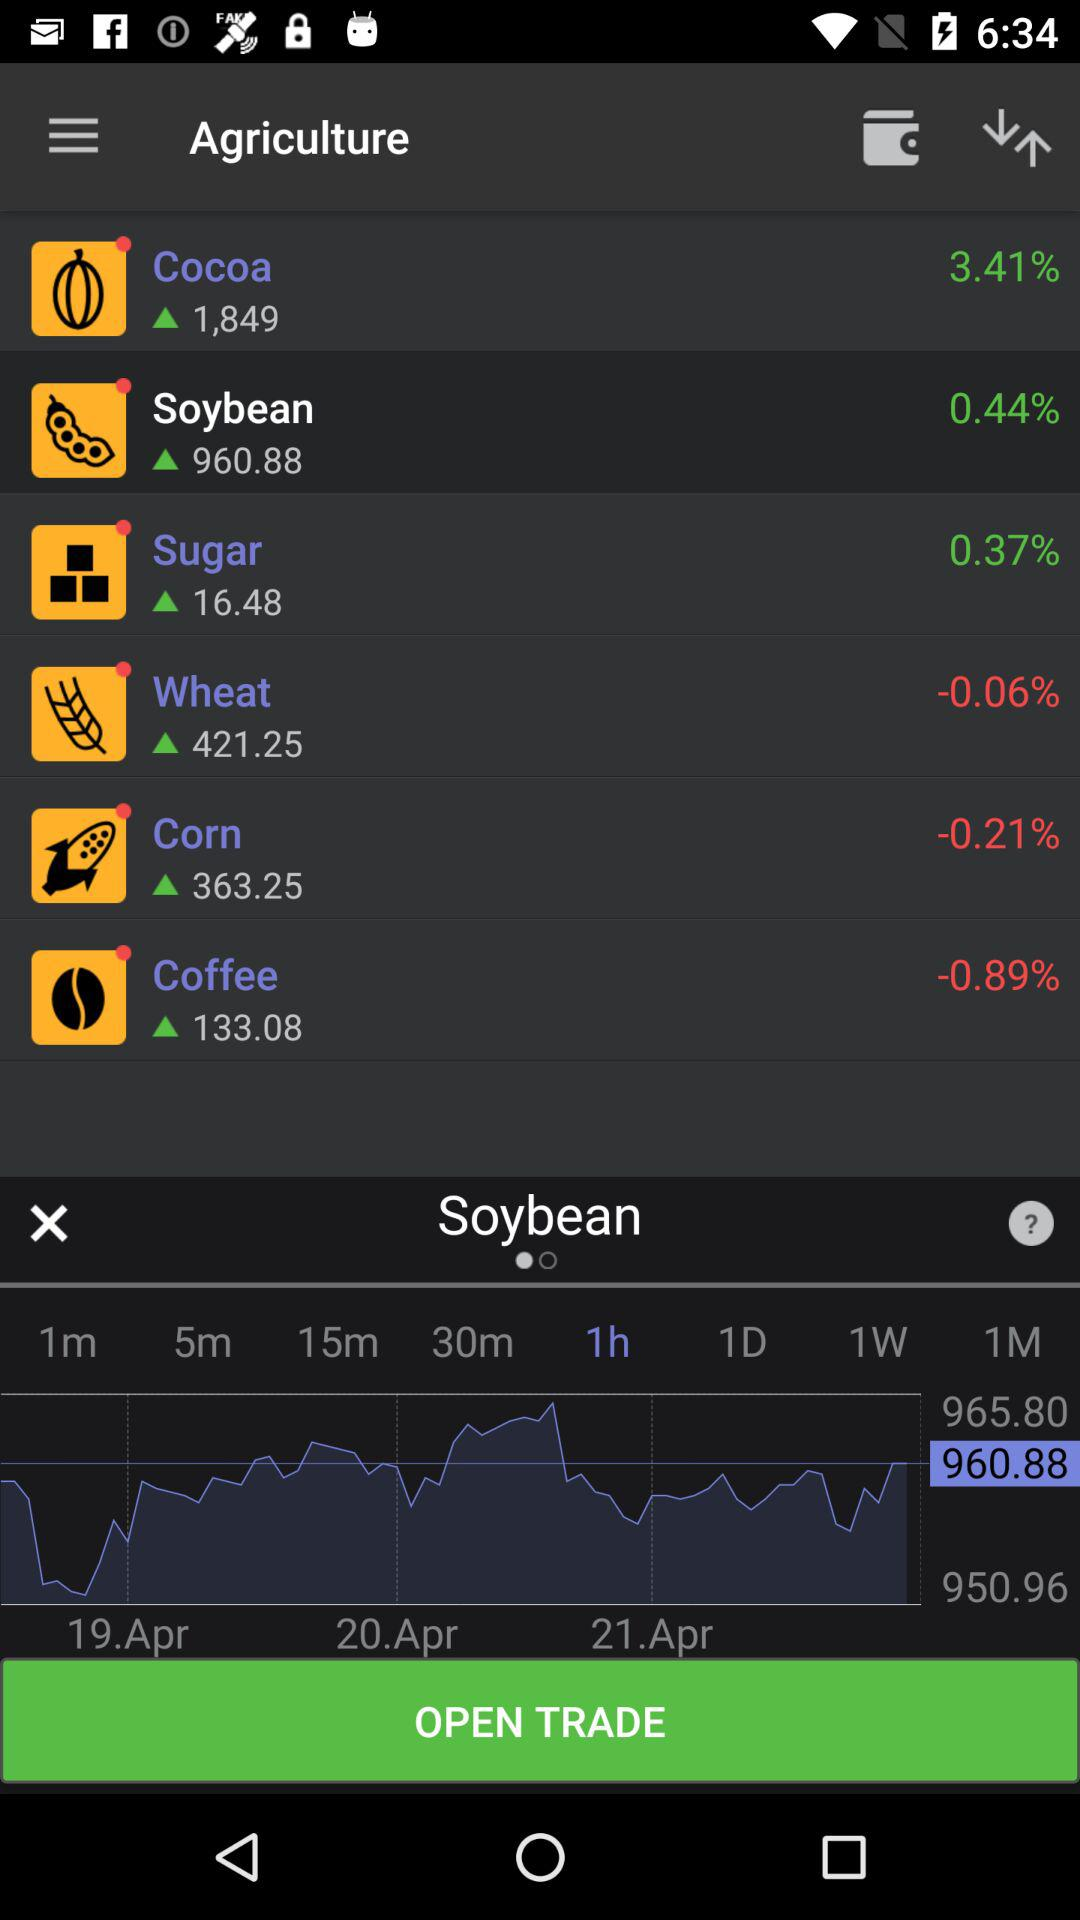What is the percentage increase in "Cocoa"? The percentage increase in "Cocoa" is 3.41. 